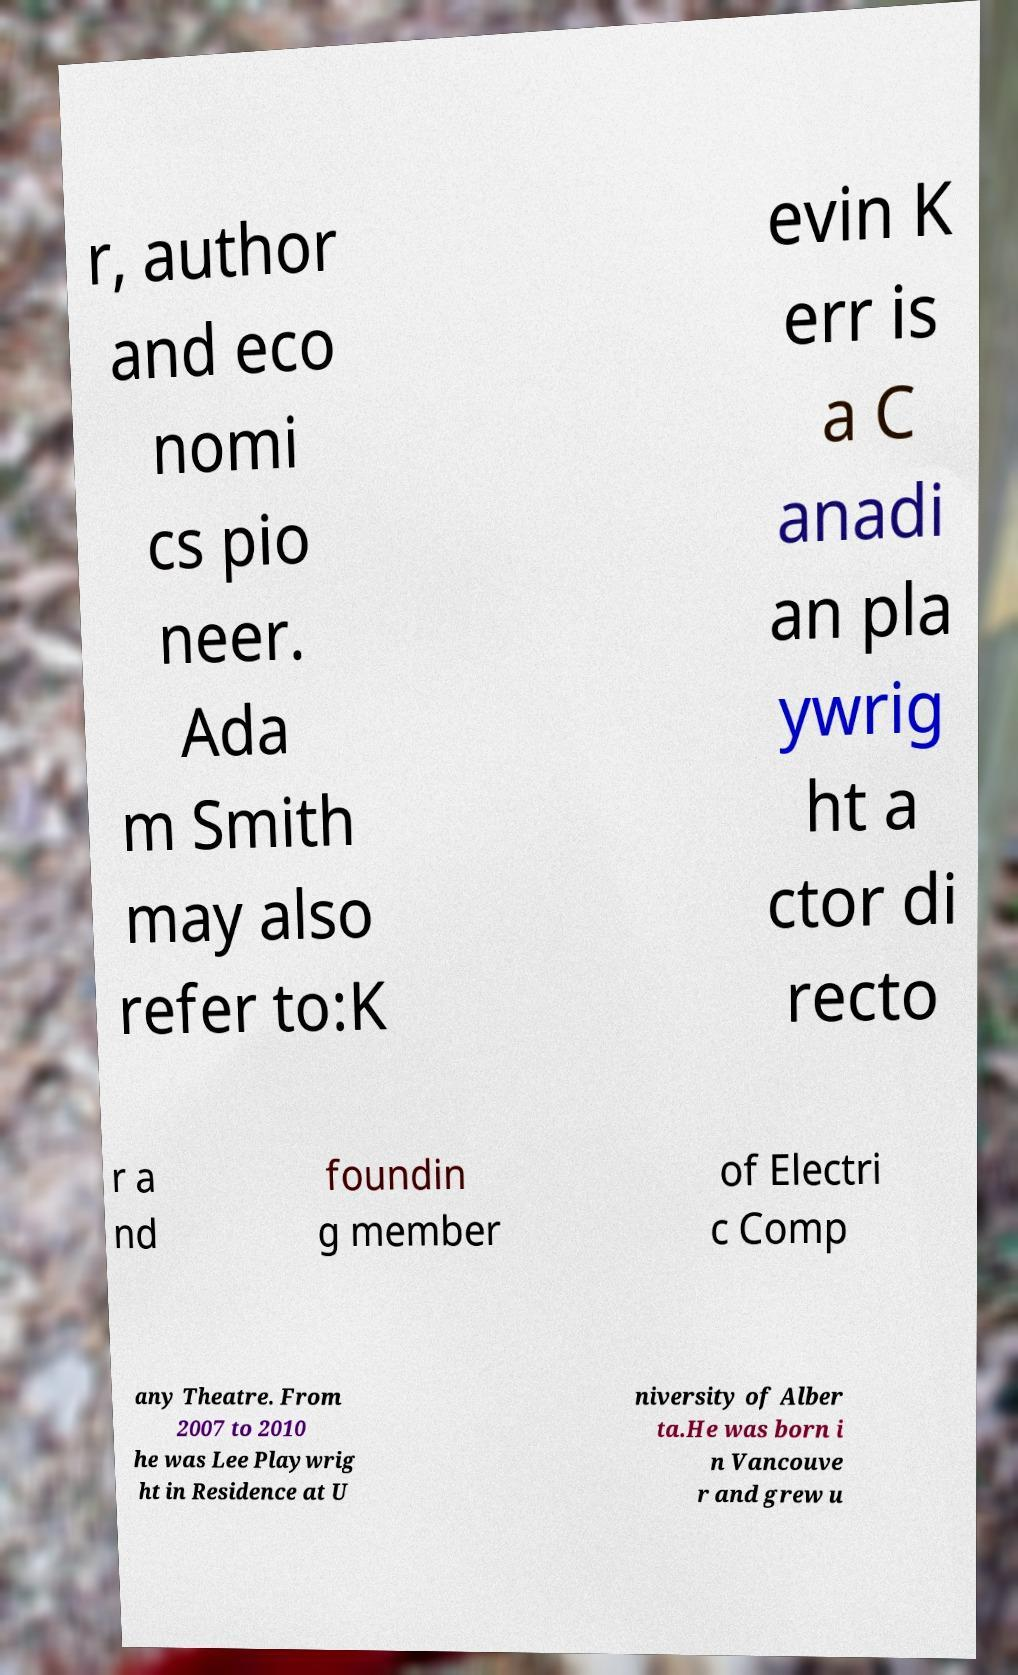I need the written content from this picture converted into text. Can you do that? r, author and eco nomi cs pio neer. Ada m Smith may also refer to:K evin K err is a C anadi an pla ywrig ht a ctor di recto r a nd foundin g member of Electri c Comp any Theatre. From 2007 to 2010 he was Lee Playwrig ht in Residence at U niversity of Alber ta.He was born i n Vancouve r and grew u 